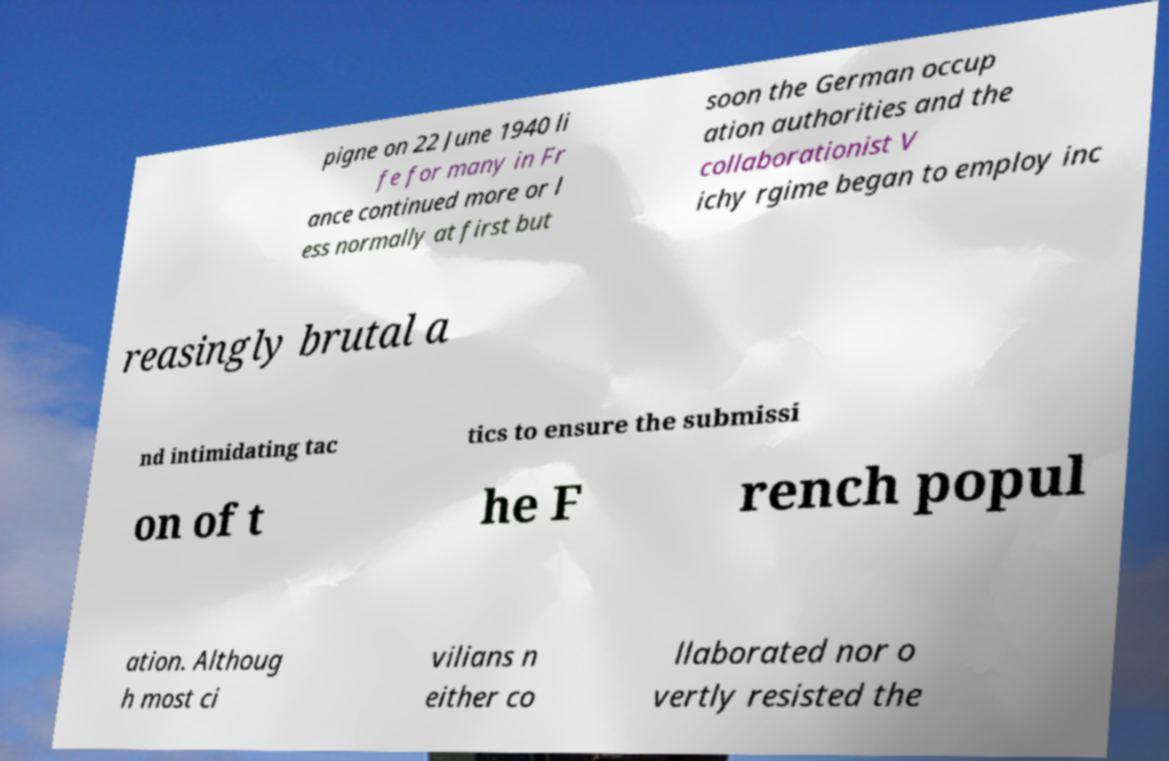Could you assist in decoding the text presented in this image and type it out clearly? pigne on 22 June 1940 li fe for many in Fr ance continued more or l ess normally at first but soon the German occup ation authorities and the collaborationist V ichy rgime began to employ inc reasingly brutal a nd intimidating tac tics to ensure the submissi on of t he F rench popul ation. Althoug h most ci vilians n either co llaborated nor o vertly resisted the 